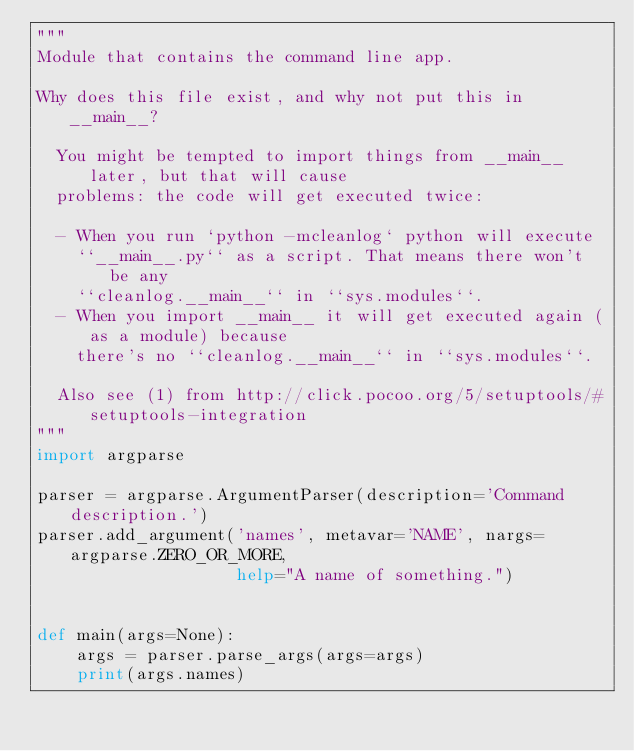Convert code to text. <code><loc_0><loc_0><loc_500><loc_500><_Python_>"""
Module that contains the command line app.

Why does this file exist, and why not put this in __main__?

  You might be tempted to import things from __main__ later, but that will cause
  problems: the code will get executed twice:

  - When you run `python -mcleanlog` python will execute
    ``__main__.py`` as a script. That means there won't be any
    ``cleanlog.__main__`` in ``sys.modules``.
  - When you import __main__ it will get executed again (as a module) because
    there's no ``cleanlog.__main__`` in ``sys.modules``.

  Also see (1) from http://click.pocoo.org/5/setuptools/#setuptools-integration
"""
import argparse

parser = argparse.ArgumentParser(description='Command description.')
parser.add_argument('names', metavar='NAME', nargs=argparse.ZERO_OR_MORE,
                    help="A name of something.")


def main(args=None):
    args = parser.parse_args(args=args)
    print(args.names)
</code> 